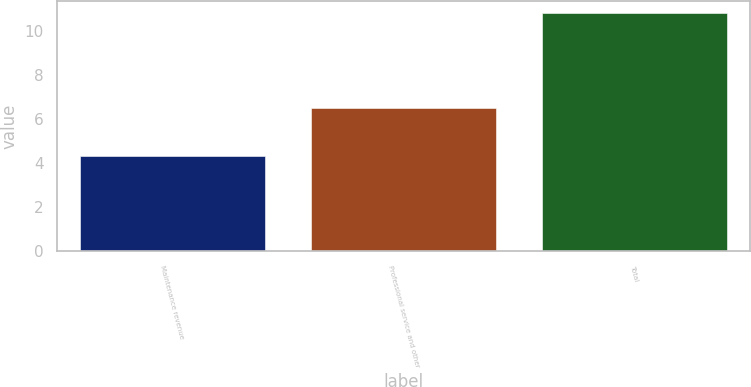<chart> <loc_0><loc_0><loc_500><loc_500><bar_chart><fcel>Maintenance revenue<fcel>Professional service and other<fcel>Total<nl><fcel>4.3<fcel>6.5<fcel>10.8<nl></chart> 